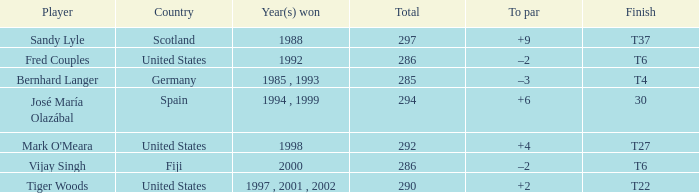Which player has +2 to par? Tiger Woods. 